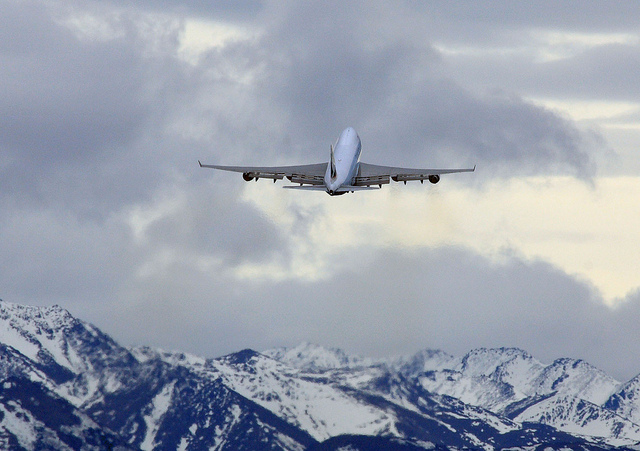How many people are shown? It appears that there are no people visible in the image, as the focus is on an airplane in flight with a background of mountains and clouds. 